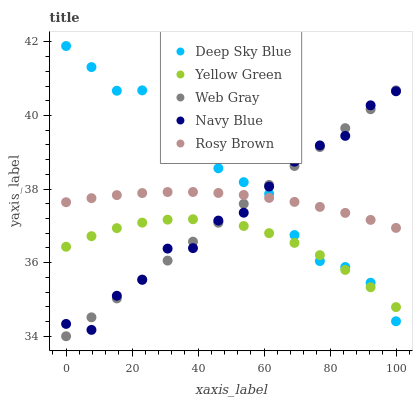Does Yellow Green have the minimum area under the curve?
Answer yes or no. Yes. Does Deep Sky Blue have the maximum area under the curve?
Answer yes or no. Yes. Does Rosy Brown have the minimum area under the curve?
Answer yes or no. No. Does Rosy Brown have the maximum area under the curve?
Answer yes or no. No. Is Web Gray the smoothest?
Answer yes or no. Yes. Is Deep Sky Blue the roughest?
Answer yes or no. Yes. Is Rosy Brown the smoothest?
Answer yes or no. No. Is Rosy Brown the roughest?
Answer yes or no. No. Does Web Gray have the lowest value?
Answer yes or no. Yes. Does Rosy Brown have the lowest value?
Answer yes or no. No. Does Deep Sky Blue have the highest value?
Answer yes or no. Yes. Does Rosy Brown have the highest value?
Answer yes or no. No. Is Yellow Green less than Rosy Brown?
Answer yes or no. Yes. Is Rosy Brown greater than Yellow Green?
Answer yes or no. Yes. Does Deep Sky Blue intersect Navy Blue?
Answer yes or no. Yes. Is Deep Sky Blue less than Navy Blue?
Answer yes or no. No. Is Deep Sky Blue greater than Navy Blue?
Answer yes or no. No. Does Yellow Green intersect Rosy Brown?
Answer yes or no. No. 